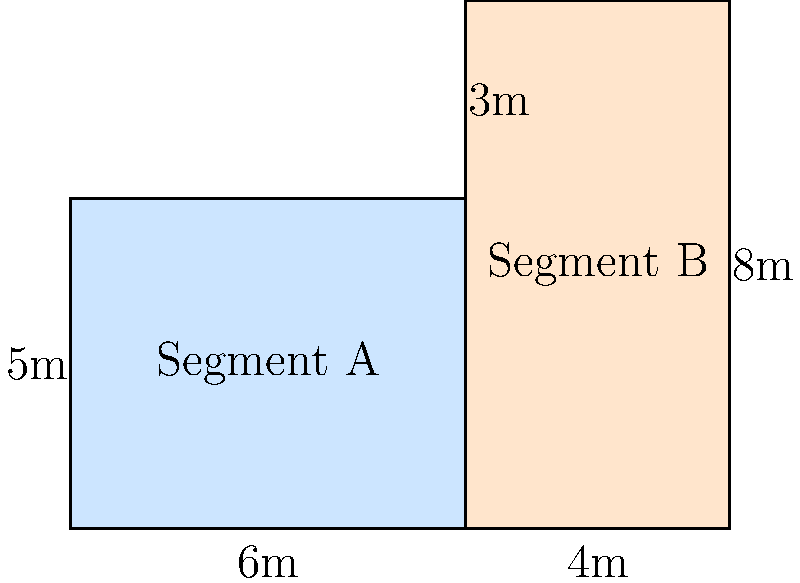In a cybersecurity project, you're tasked with calculating the total area of network segments in an office floor plan to determine the coverage needed for intrusion detection sensors. The floor plan is divided into two irregular-shaped segments as shown. Segment A is a rectangle, while Segment B is an L-shaped area. Given the dimensions in the diagram, what is the total area (in square meters) that needs to be covered by the intrusion detection system? To solve this problem, we need to calculate the areas of both segments and sum them up:

1. Calculate the area of Segment A (rectangle):
   $A_A = 6m \times 5m = 30m^2$

2. Calculate the area of Segment B (L-shaped):
   - We can split this into two rectangles:
     a. Lower rectangle: $4m \times 5m = 20m^2$
     b. Upper rectangle: $4m \times 3m = 12m^2$
   $A_B = 20m^2 + 12m^2 = 32m^2$

3. Calculate the total area:
   $A_{total} = A_A + A_B = 30m^2 + 32m^2 = 62m^2$

Therefore, the total area that needs to be covered by the intrusion detection system is 62 square meters.
Answer: 62 m² 